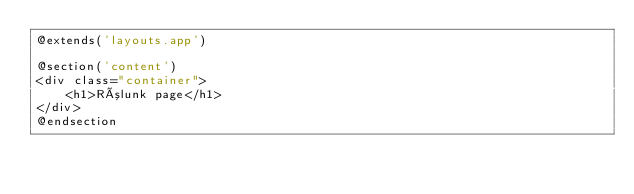<code> <loc_0><loc_0><loc_500><loc_500><_PHP_>@extends('layouts.app')

@section('content')
<div class="container">
    <h1>Rólunk page</h1>
</div>
@endsection
</code> 